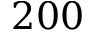Convert formula to latex. <formula><loc_0><loc_0><loc_500><loc_500>2 0 0</formula> 